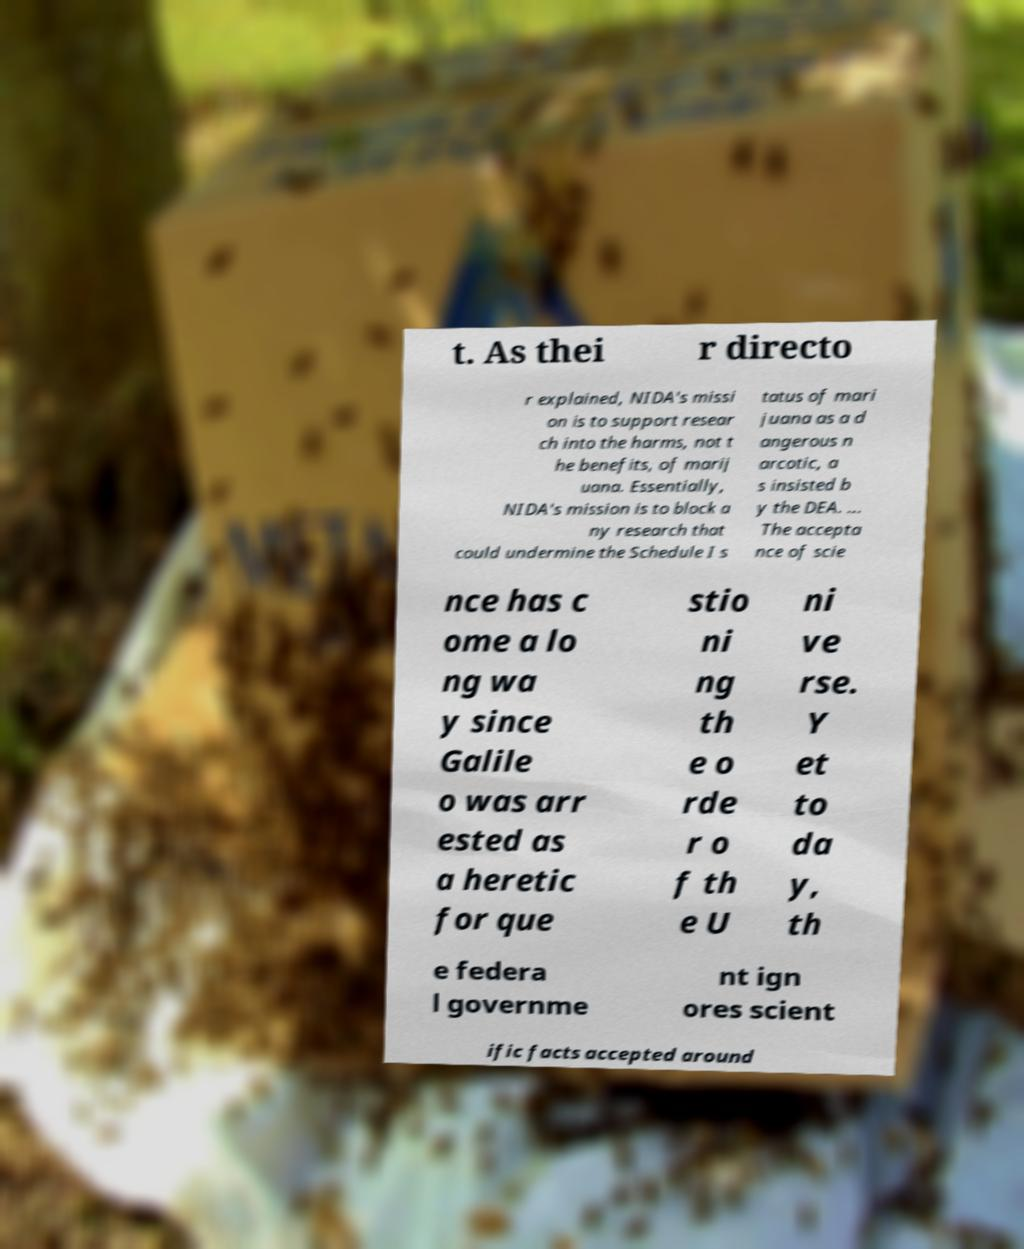For documentation purposes, I need the text within this image transcribed. Could you provide that? t. As thei r directo r explained, NIDA's missi on is to support resear ch into the harms, not t he benefits, of marij uana. Essentially, NIDA's mission is to block a ny research that could undermine the Schedule I s tatus of mari juana as a d angerous n arcotic, a s insisted b y the DEA. ... The accepta nce of scie nce has c ome a lo ng wa y since Galile o was arr ested as a heretic for que stio ni ng th e o rde r o f th e U ni ve rse. Y et to da y, th e federa l governme nt ign ores scient ific facts accepted around 